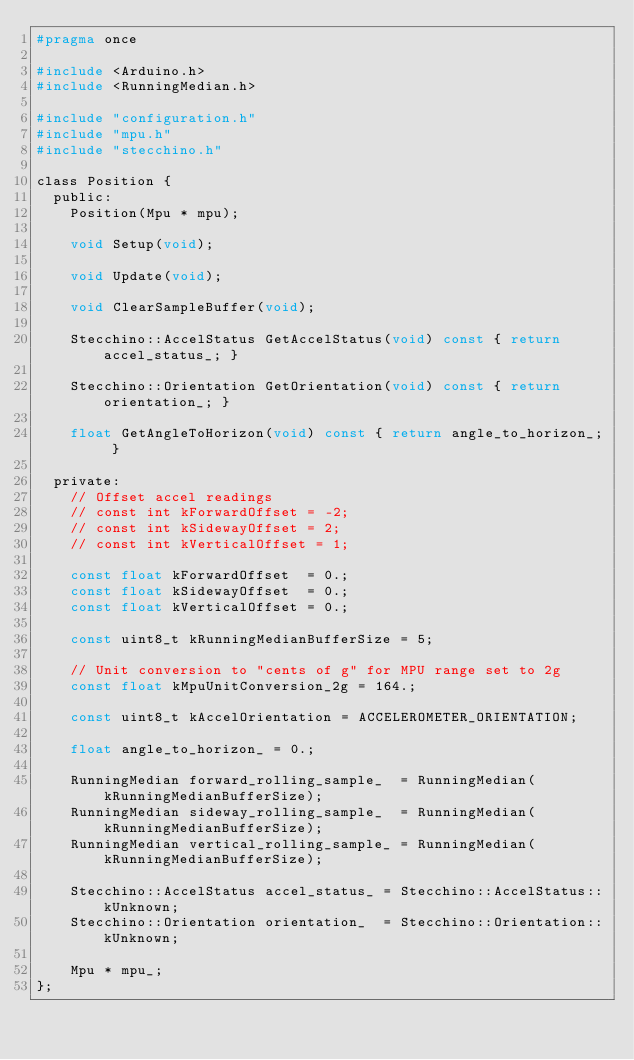Convert code to text. <code><loc_0><loc_0><loc_500><loc_500><_C_>#pragma once

#include <Arduino.h>
#include <RunningMedian.h>

#include "configuration.h"
#include "mpu.h"
#include "stecchino.h"

class Position {
  public:
    Position(Mpu * mpu);

    void Setup(void);

    void Update(void);

    void ClearSampleBuffer(void);

    Stecchino::AccelStatus GetAccelStatus(void) const { return accel_status_; }

    Stecchino::Orientation GetOrientation(void) const { return orientation_; }

    float GetAngleToHorizon(void) const { return angle_to_horizon_; }

  private:
    // Offset accel readings
    // const int kForwardOffset = -2;
    // const int kSidewayOffset = 2;
    // const int kVerticalOffset = 1;

    const float kForwardOffset  = 0.;
    const float kSidewayOffset  = 0.;
    const float kVerticalOffset = 0.;

    const uint8_t kRunningMedianBufferSize = 5;

    // Unit conversion to "cents of g" for MPU range set to 2g
    const float kMpuUnitConversion_2g = 164.;

    const uint8_t kAccelOrientation = ACCELEROMETER_ORIENTATION;

    float angle_to_horizon_ = 0.;

    RunningMedian forward_rolling_sample_  = RunningMedian(kRunningMedianBufferSize);
    RunningMedian sideway_rolling_sample_  = RunningMedian(kRunningMedianBufferSize);
    RunningMedian vertical_rolling_sample_ = RunningMedian(kRunningMedianBufferSize);

    Stecchino::AccelStatus accel_status_ = Stecchino::AccelStatus::kUnknown;
    Stecchino::Orientation orientation_  = Stecchino::Orientation::kUnknown;

    Mpu * mpu_;
};
</code> 